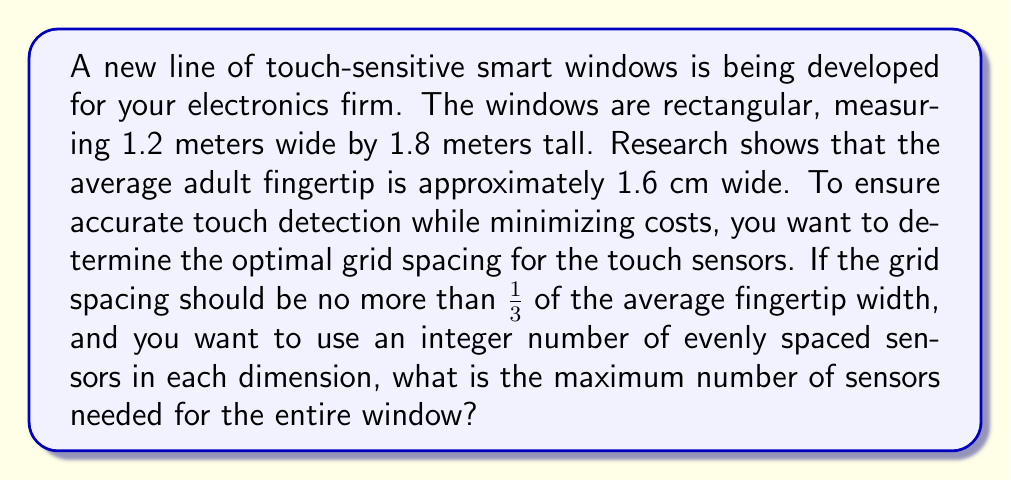Give your solution to this math problem. To solve this problem, we'll follow these steps:

1. Calculate the maximum grid spacing:
   The maximum grid spacing should be 1/3 of the average fingertip width.
   $$\text{Max grid spacing} = \frac{1.6 \text{ cm}}{3} = \frac{16 \text{ mm}}{3} \approx 5.33 \text{ mm}$$

2. Convert window dimensions to millimeters:
   $$\text{Width} = 1.2 \text{ m} = 1200 \text{ mm}$$
   $$\text{Height} = 1.8 \text{ m} = 1800 \text{ mm}$$

3. Calculate the minimum number of sensors needed for each dimension:
   For width: $$\text{Sensors}_w = \left\lceil\frac{1200 \text{ mm}}{5.33 \text{ mm}}\right\rceil = \left\lceil225\right\rceil = 225$$
   For height: $$\text{Sensors}_h = \left\lceil\frac{1800 \text{ mm}}{5.33 \text{ mm}}\right\rceil = \left\lceil337.5\right\rceil = 338$$

4. Adjust to use an integer number of evenly spaced sensors:
   For width: Use 225 sensors, giving a spacing of $\frac{1200 \text{ mm}}{225} \approx 5.33 \text{ mm}$
   For height: Use 338 sensors, giving a spacing of $\frac{1800 \text{ mm}}{338} \approx 5.33 \text{ mm}$

5. Calculate the total number of sensors:
   $$\text{Total sensors} = 225 \times 338 = 76,050$$

Therefore, the maximum number of sensors needed for the entire window is 76,050.
Answer: 76,050 sensors 